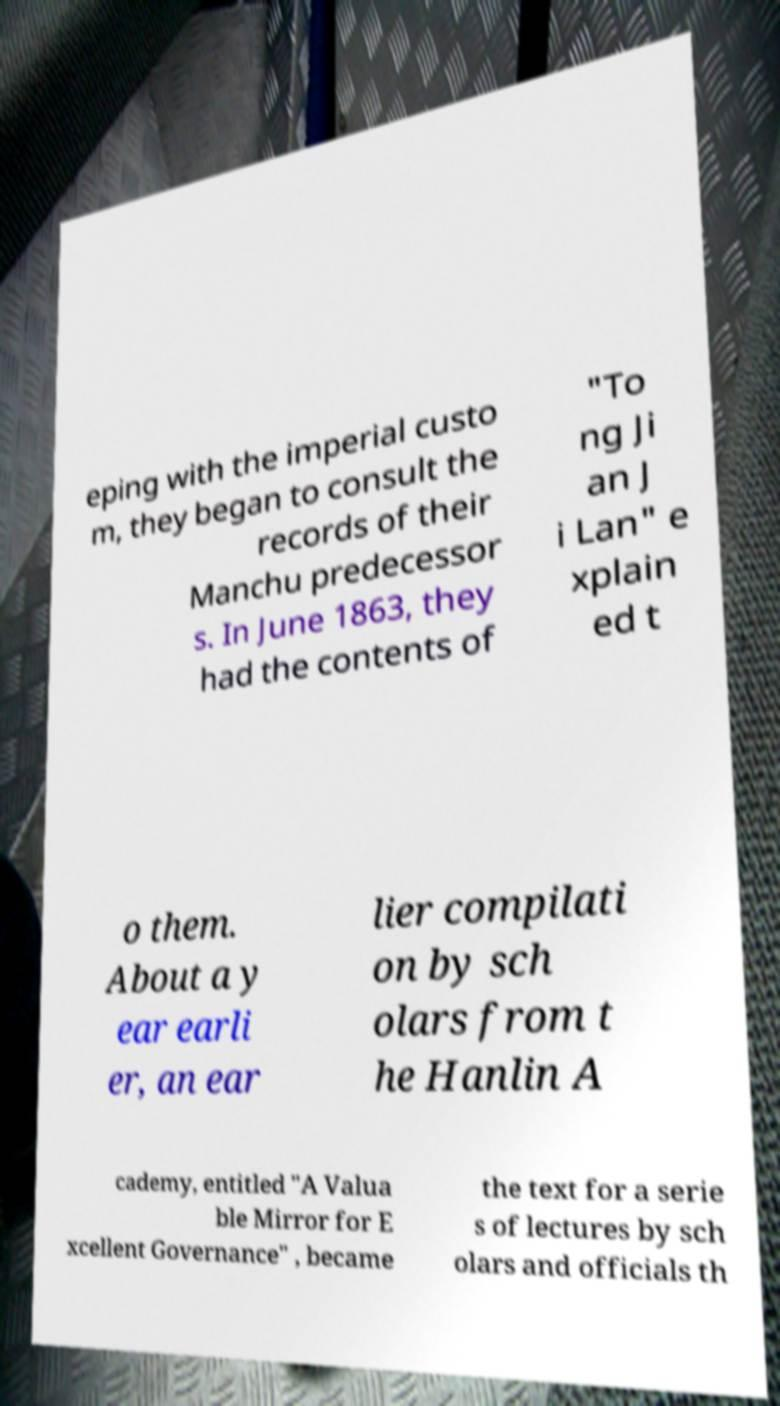Can you accurately transcribe the text from the provided image for me? eping with the imperial custo m, they began to consult the records of their Manchu predecessor s. In June 1863, they had the contents of "To ng Ji an J i Lan" e xplain ed t o them. About a y ear earli er, an ear lier compilati on by sch olars from t he Hanlin A cademy, entitled "A Valua ble Mirror for E xcellent Governance" , became the text for a serie s of lectures by sch olars and officials th 